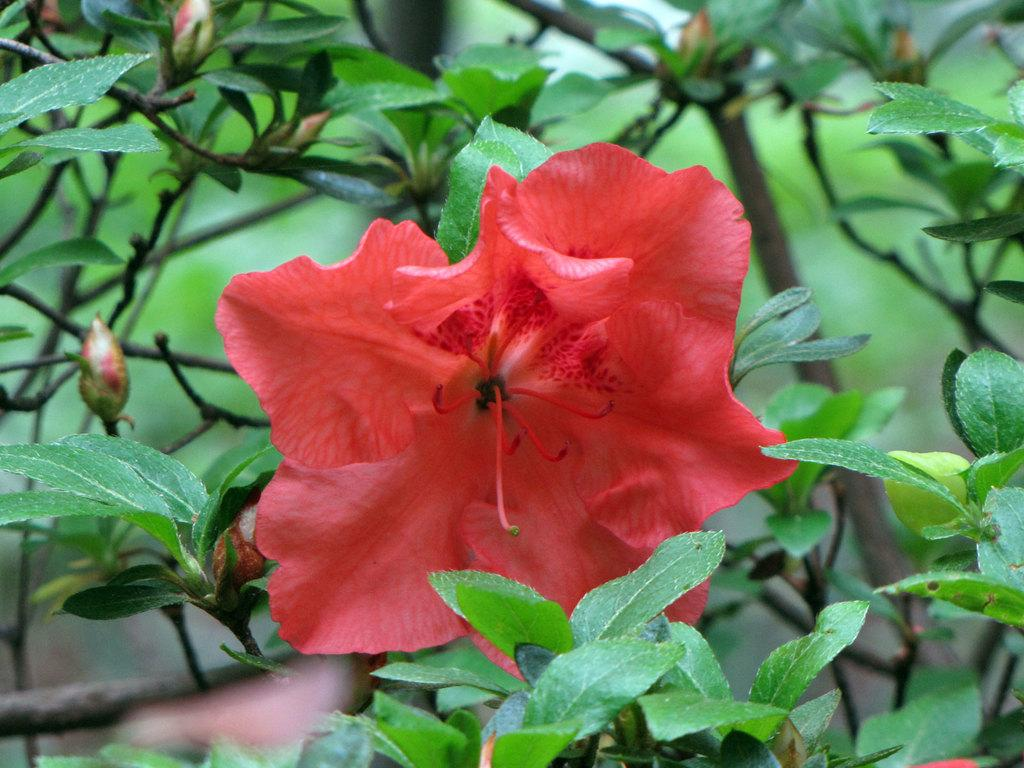What type of plant can be seen in the image? There is a flower in the image. What else can be seen related to the plant in the image? There are leaves of a tree in the image. What type of feast is being prepared with the flower in the image? There is no feast or preparation for a feast visible in the image; it only features a flower and tree leaves. 